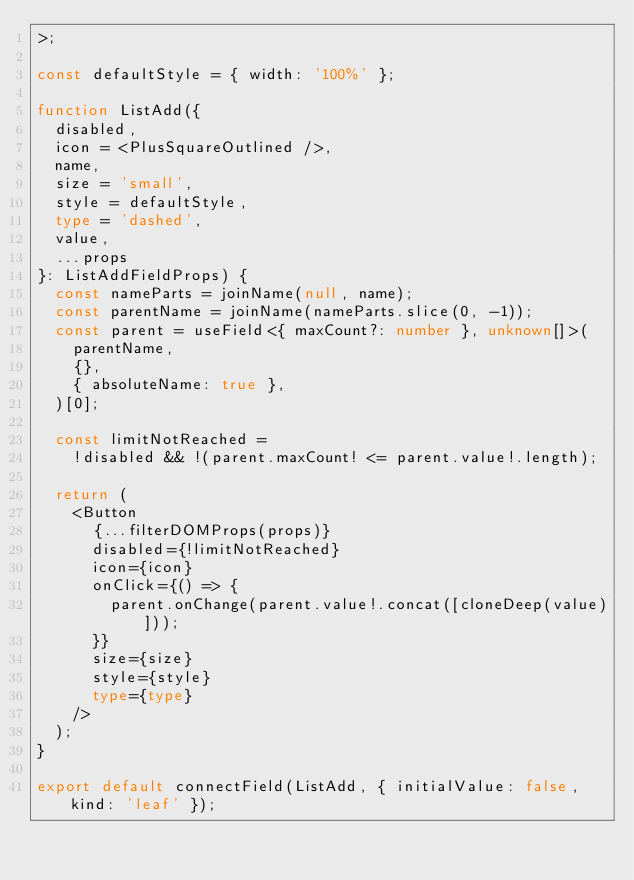Convert code to text. <code><loc_0><loc_0><loc_500><loc_500><_TypeScript_>>;

const defaultStyle = { width: '100%' };

function ListAdd({
  disabled,
  icon = <PlusSquareOutlined />,
  name,
  size = 'small',
  style = defaultStyle,
  type = 'dashed',
  value,
  ...props
}: ListAddFieldProps) {
  const nameParts = joinName(null, name);
  const parentName = joinName(nameParts.slice(0, -1));
  const parent = useField<{ maxCount?: number }, unknown[]>(
    parentName,
    {},
    { absoluteName: true },
  )[0];

  const limitNotReached =
    !disabled && !(parent.maxCount! <= parent.value!.length);

  return (
    <Button
      {...filterDOMProps(props)}
      disabled={!limitNotReached}
      icon={icon}
      onClick={() => {
        parent.onChange(parent.value!.concat([cloneDeep(value)]));
      }}
      size={size}
      style={style}
      type={type}
    />
  );
}

export default connectField(ListAdd, { initialValue: false, kind: 'leaf' });
</code> 